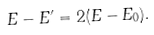<formula> <loc_0><loc_0><loc_500><loc_500>E - E ^ { \prime } = 2 ( E - E _ { 0 } ) .</formula> 